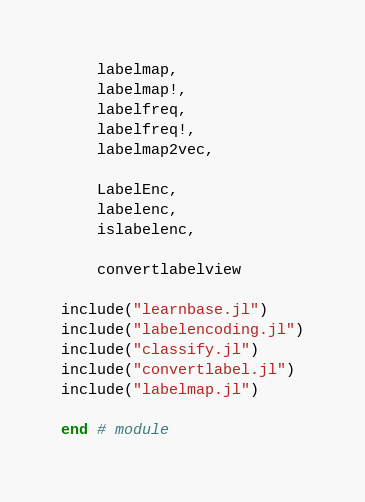<code> <loc_0><loc_0><loc_500><loc_500><_Julia_>
    labelmap,
    labelmap!,
    labelfreq,
    labelfreq!,
    labelmap2vec,

    LabelEnc,
    labelenc,
    islabelenc,

    convertlabelview

include("learnbase.jl")
include("labelencoding.jl")
include("classify.jl")
include("convertlabel.jl")
include("labelmap.jl")

end # module
</code> 